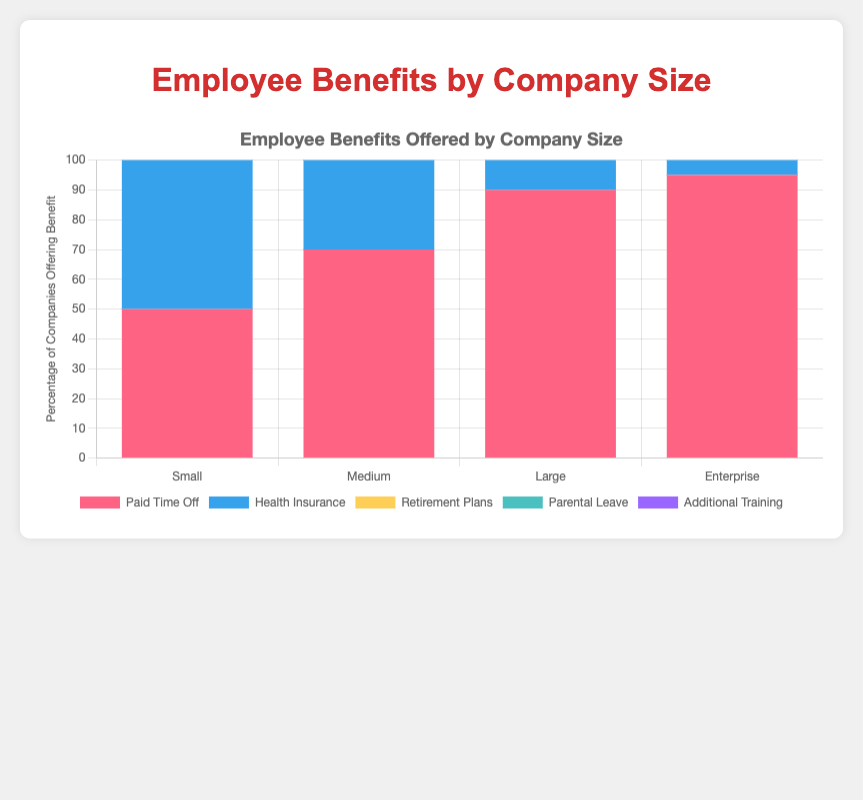Which company size offers the highest percentage of "Paid Time Off"? By examining the stacked bar chart, we can see the height for "Paid Time Off" is highest for the "Enterprise" company size.
Answer: Enterprise Compared to "Medium" companies, how much more "Retirement Plans" do "Large" companies offer? The bar for "Retirement Plans" in "Medium" companies is at 60%, while for "Large" companies it is at 85%. The difference is 85 - 60 = 25%.
Answer: 25% Which benefit is least offered by "Small" companies? By observing the chart, "Parental Leave" has the smallest section within the "Small" company size bar at 20%.
Answer: Parental Leave Is the percentage of companies offering "Health Insurance" always greater than the percentage offering "Paid Time Off" across all company sizes? By examining each company size on the chart, for "Small," "Medium," "Large," and "Enterprise," "Health Insurance" is always higher than "Paid Time Off."
Answer: Yes What is the total percentage of "Additional Training" offered by all company sizes combined? Summing up the percentages for "Additional Training": Small (40) + Medium (60) + Large (85) + Enterprise (90) gives 275%.
Answer: 275% Which benefit shows the most significant increase from "Small" to "Enterprise" company size? By comparing the bars, "Retirement Plans" increases from 30% in "Small" to 90% in "Enterprise," which is an increase of 60%.
Answer: Retirement Plans For "Medium" companies, what is the combined percentage of "Parental Leave" and "Health Insurance"? Adding the values for "Parental Leave" (45%) and "Health Insurance" (80%) in medium companies results in 45 + 80 = 125%.
Answer: 125% Do "Large" companies offer more "Additional Training" than "Parental Leave"? Observing the bar for "Large" companies, "Additional Training" is at 85%, while "Parental Leave" is at 70%. This shows that "Additional Training" is indeed more than "Parental Leave".
Answer: Yes What percentage of "Small" companies offer "Health Insurance"? Looking at the "Small" company size bar, it shows that 60% of these companies offer "Health Insurance".
Answer: 60% Which company size offers the most "Parental Leave"? The tallest "Parental Leave" section is found in the "Enterprise" company size at 80%.
Answer: Enterprise 